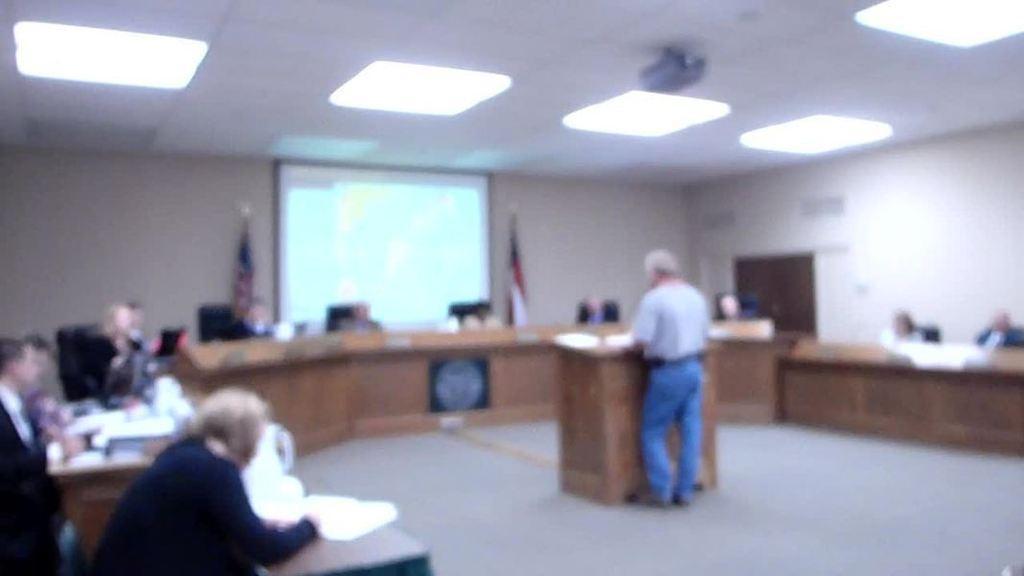How would you summarize this image in a sentence or two? In the foreground I can see a group of people are sitting on the chairs in front of a desk on which some objects are placed and a person is standing in front of a standing table. In the background I can see a screen, wall, door and lights on a rooftop. This image is taken may be in a hall. 